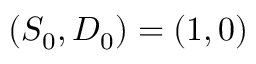Convert formula to latex. <formula><loc_0><loc_0><loc_500><loc_500>( S _ { 0 } , D _ { 0 } ) = ( 1 , 0 )</formula> 